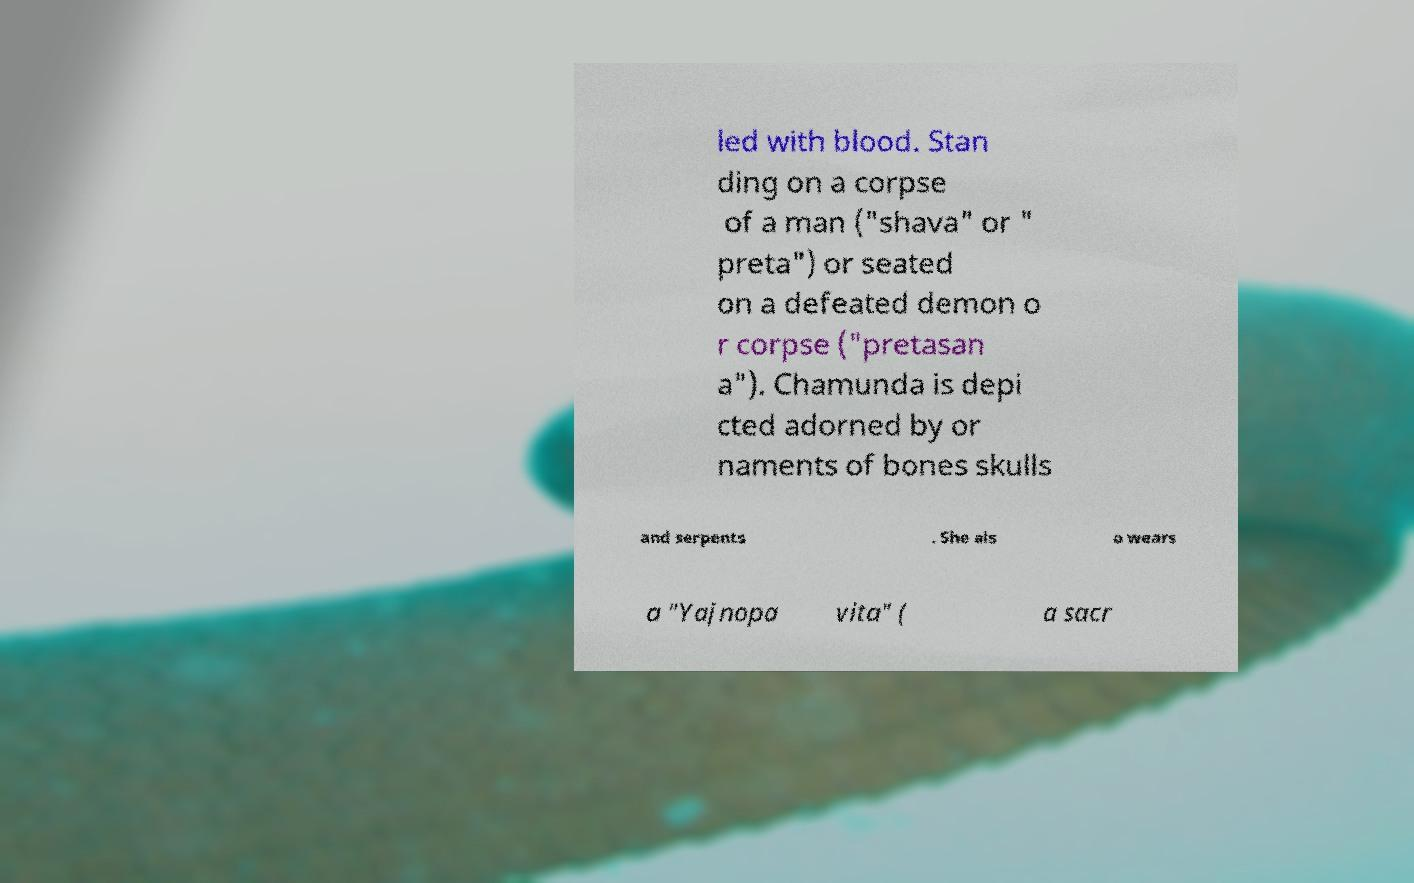There's text embedded in this image that I need extracted. Can you transcribe it verbatim? led with blood. Stan ding on a corpse of a man ("shava" or " preta") or seated on a defeated demon o r corpse ("pretasan a"). Chamunda is depi cted adorned by or naments of bones skulls and serpents . She als o wears a "Yajnopa vita" ( a sacr 